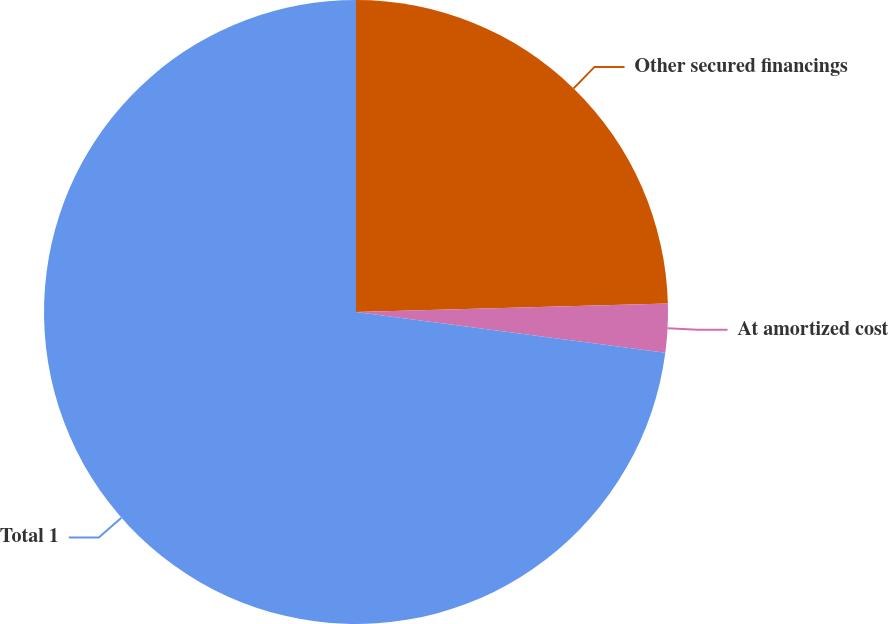Convert chart to OTSL. <chart><loc_0><loc_0><loc_500><loc_500><pie_chart><fcel>Other secured financings<fcel>At amortized cost<fcel>Total 1<nl><fcel>24.57%<fcel>2.52%<fcel>72.91%<nl></chart> 